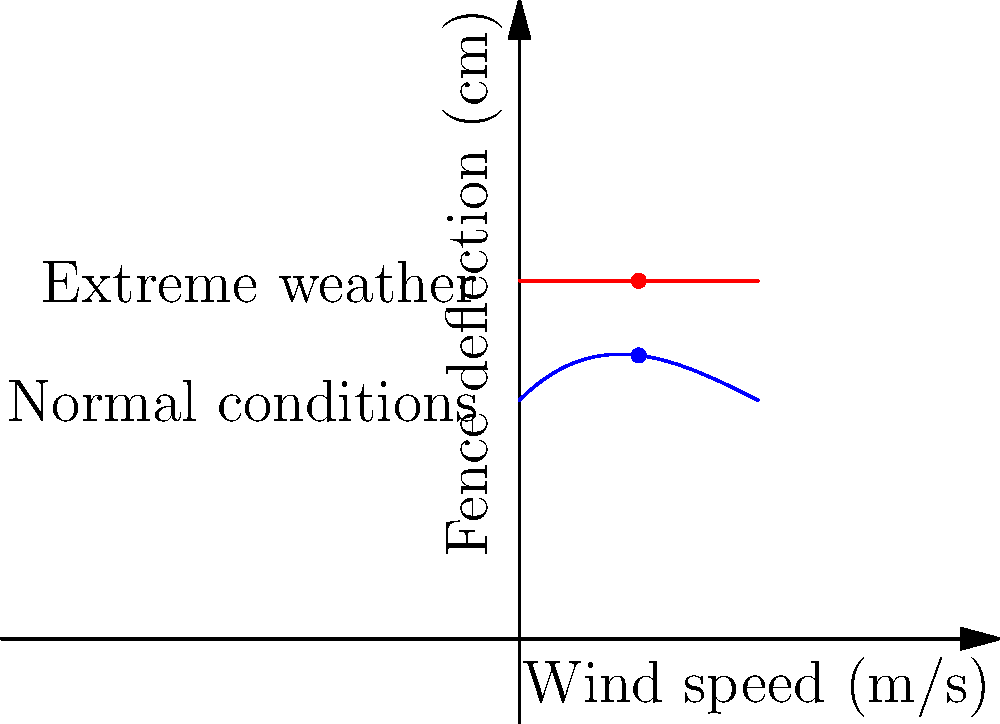As the prison warden, you're concerned about the structural integrity of the perimeter fence during extreme weather conditions. The graph shows the fence deflection under normal conditions (blue curve) and extreme weather (red line). If the wind speed reaches 5 m/s, what is the difference in fence deflection (in cm) between extreme weather and normal conditions? To solve this problem, we need to follow these steps:

1. Identify the fence deflection at 5 m/s wind speed for normal conditions:
   - From the blue curve, at x = 5 m/s, y ≈ 11.875 cm

2. Identify the fence deflection at 5 m/s wind speed for extreme weather:
   - The red line is constant at y = 15 cm for all wind speeds

3. Calculate the difference in deflection:
   $\text{Difference} = \text{Extreme weather deflection} - \text{Normal conditions deflection}$
   $\text{Difference} = 15 \text{ cm} - 11.875 \text{ cm} = 3.125 \text{ cm}$

Therefore, the difference in fence deflection between extreme weather and normal conditions at 5 m/s wind speed is approximately 3.125 cm.
Answer: 3.125 cm 